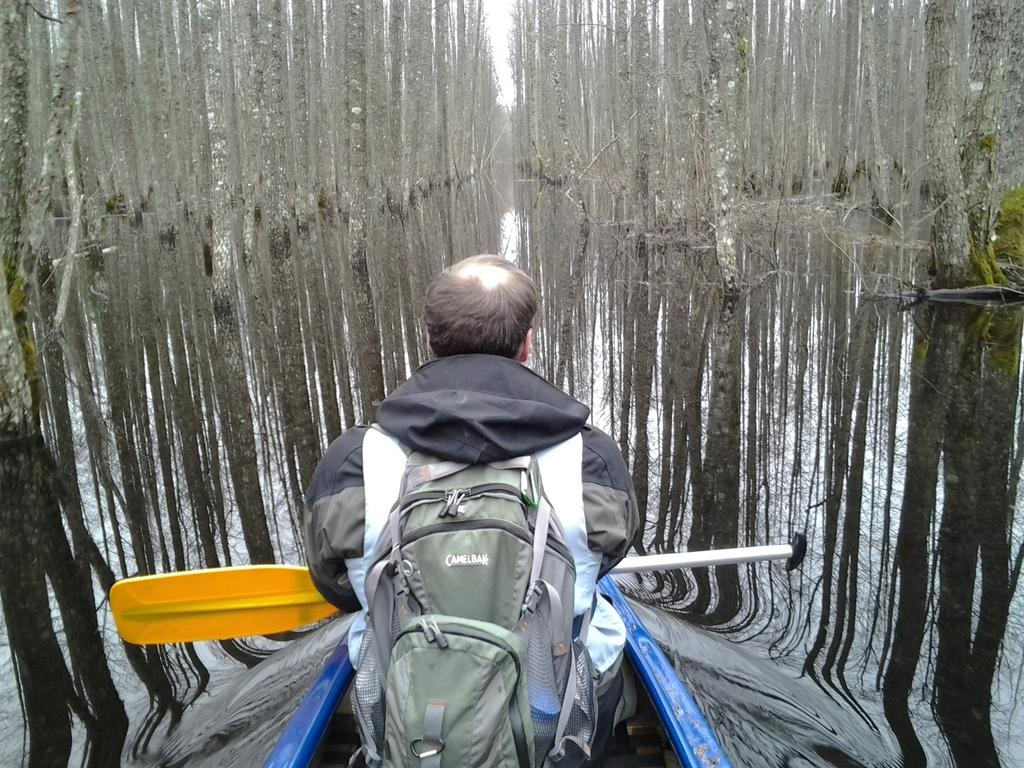What is the person in the image doing? The person is sitting on a boat. What is the person holding in the image? The person is holding a paddle. Where is the boat located? The boat is on the water. What can be seen in the background of the image? There are trees and the sky visible in the background of the image. What type of drum can be heard playing in the background of the image? There is no drum or sound present in the image; it is a still image of a person sitting on a boat. 